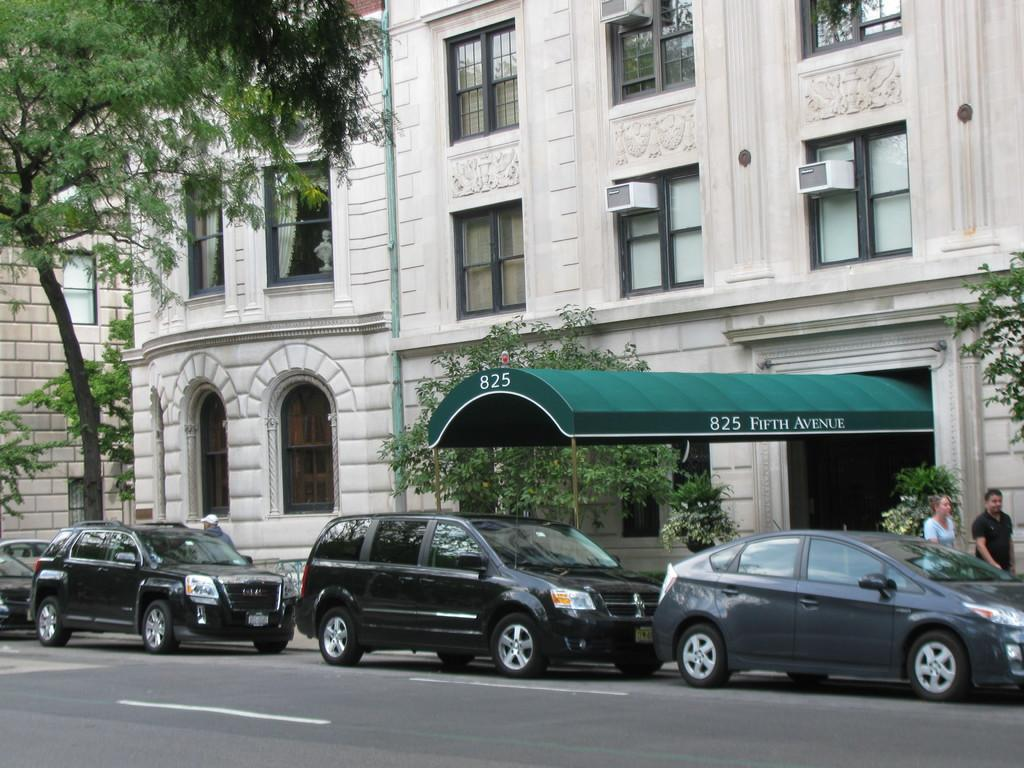What type of vehicles can be seen on the road in the image? There are cars on the road in the image. What structure is visible in the image? There is a building visible in the image. What type of natural elements can be seen in the image? There are trees in the image. Can you describe the people in the image? Two persons are standing on the right side of the image. What type of rose is being ploughed by the person in the image? There is no rose or plough present in the image. Can you describe the type of berry that the person is holding in the image? There is no berry present in the image. 